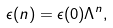<formula> <loc_0><loc_0><loc_500><loc_500>\epsilon ( n ) = \epsilon ( 0 ) \Lambda ^ { n } ,</formula> 